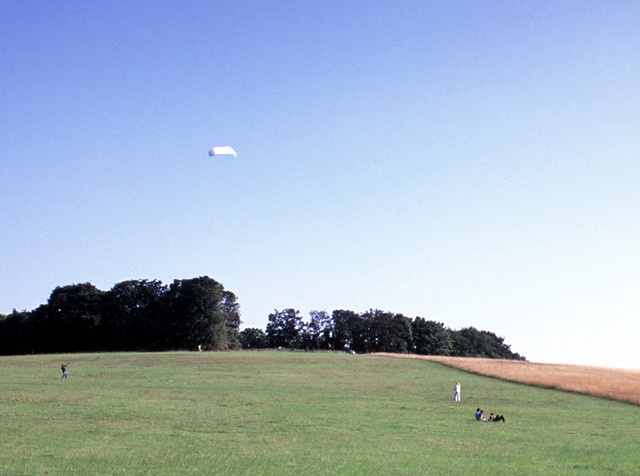Describe the objects in this image and their specific colors. I can see kite in gray, white, darkgray, and lavender tones, people in gray and darkgray tones, people in gray, white, and darkgray tones, people in gray, black, and olive tones, and people in gray, navy, black, and blue tones in this image. 